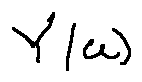<formula> <loc_0><loc_0><loc_500><loc_500>Y ( u )</formula> 